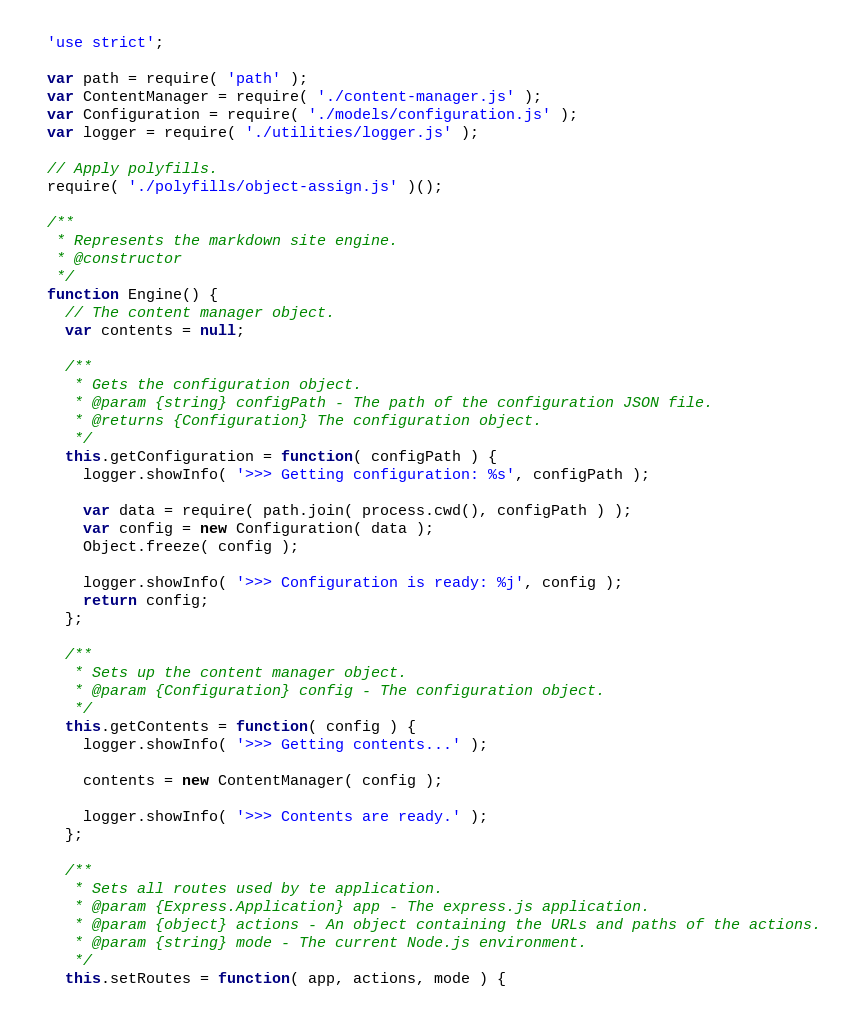Convert code to text. <code><loc_0><loc_0><loc_500><loc_500><_JavaScript_>'use strict';

var path = require( 'path' );
var ContentManager = require( './content-manager.js' );
var Configuration = require( './models/configuration.js' );
var logger = require( './utilities/logger.js' );

// Apply polyfills.
require( './polyfills/object-assign.js' )();

/**
 * Represents the markdown site engine.
 * @constructor
 */
function Engine() {
  // The content manager object.
  var contents = null;

  /**
   * Gets the configuration object.
   * @param {string} configPath - The path of the configuration JSON file.
   * @returns {Configuration} The configuration object.
   */
  this.getConfiguration = function( configPath ) {
    logger.showInfo( '>>> Getting configuration: %s', configPath );

    var data = require( path.join( process.cwd(), configPath ) );
    var config = new Configuration( data );
    Object.freeze( config );

    logger.showInfo( '>>> Configuration is ready: %j', config );
    return config;
  };

  /**
   * Sets up the content manager object.
   * @param {Configuration} config - The configuration object.
   */
  this.getContents = function( config ) {
    logger.showInfo( '>>> Getting contents...' );

    contents = new ContentManager( config );

    logger.showInfo( '>>> Contents are ready.' );
  };

  /**
   * Sets all routes used by te application.
   * @param {Express.Application} app - The express.js application.
   * @param {object} actions - An object containing the URLs and paths of the actions.
   * @param {string} mode - The current Node.js environment.
   */
  this.setRoutes = function( app, actions, mode ) {</code> 